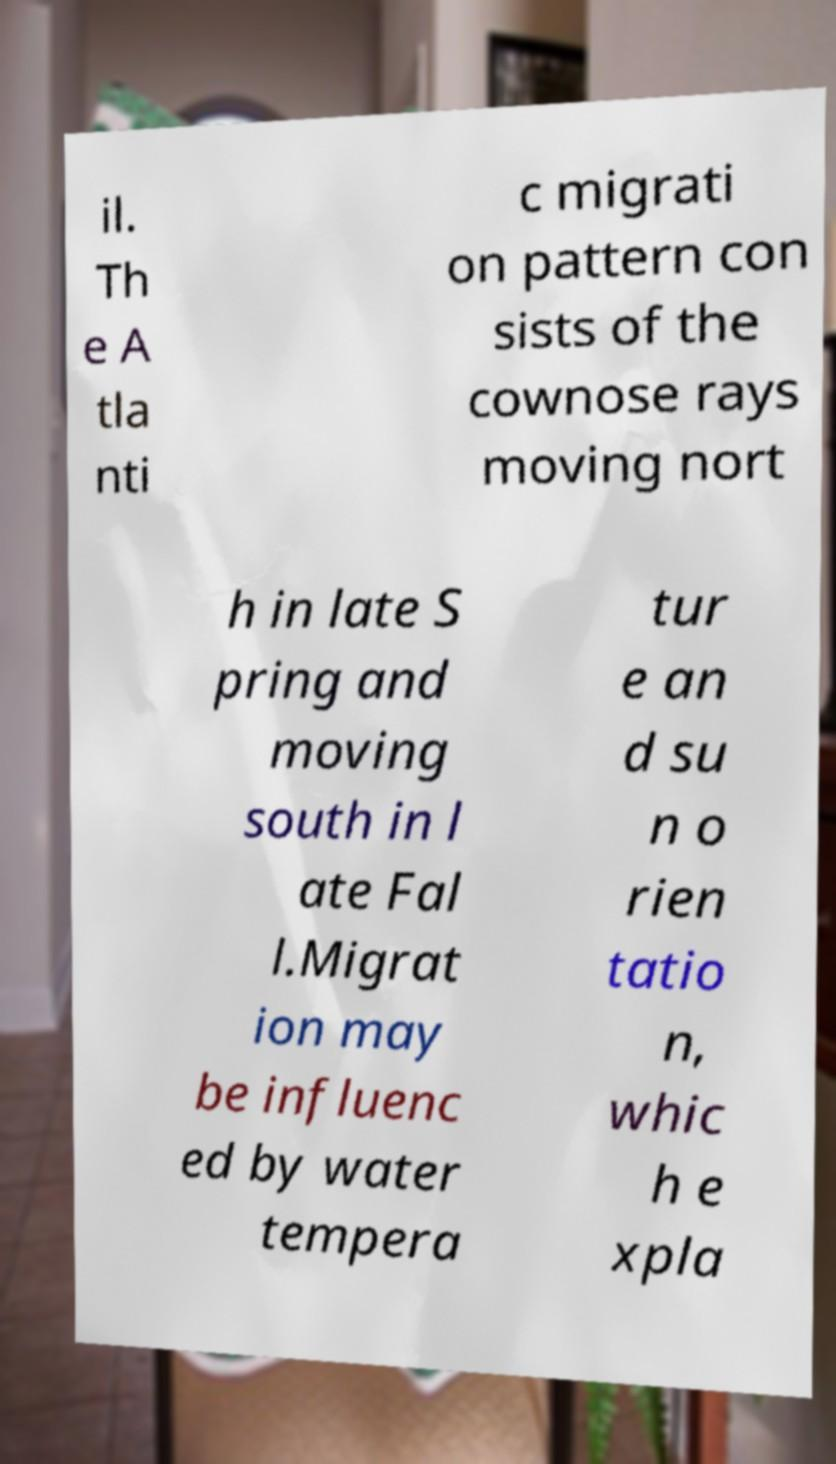Could you assist in decoding the text presented in this image and type it out clearly? il. Th e A tla nti c migrati on pattern con sists of the cownose rays moving nort h in late S pring and moving south in l ate Fal l.Migrat ion may be influenc ed by water tempera tur e an d su n o rien tatio n, whic h e xpla 